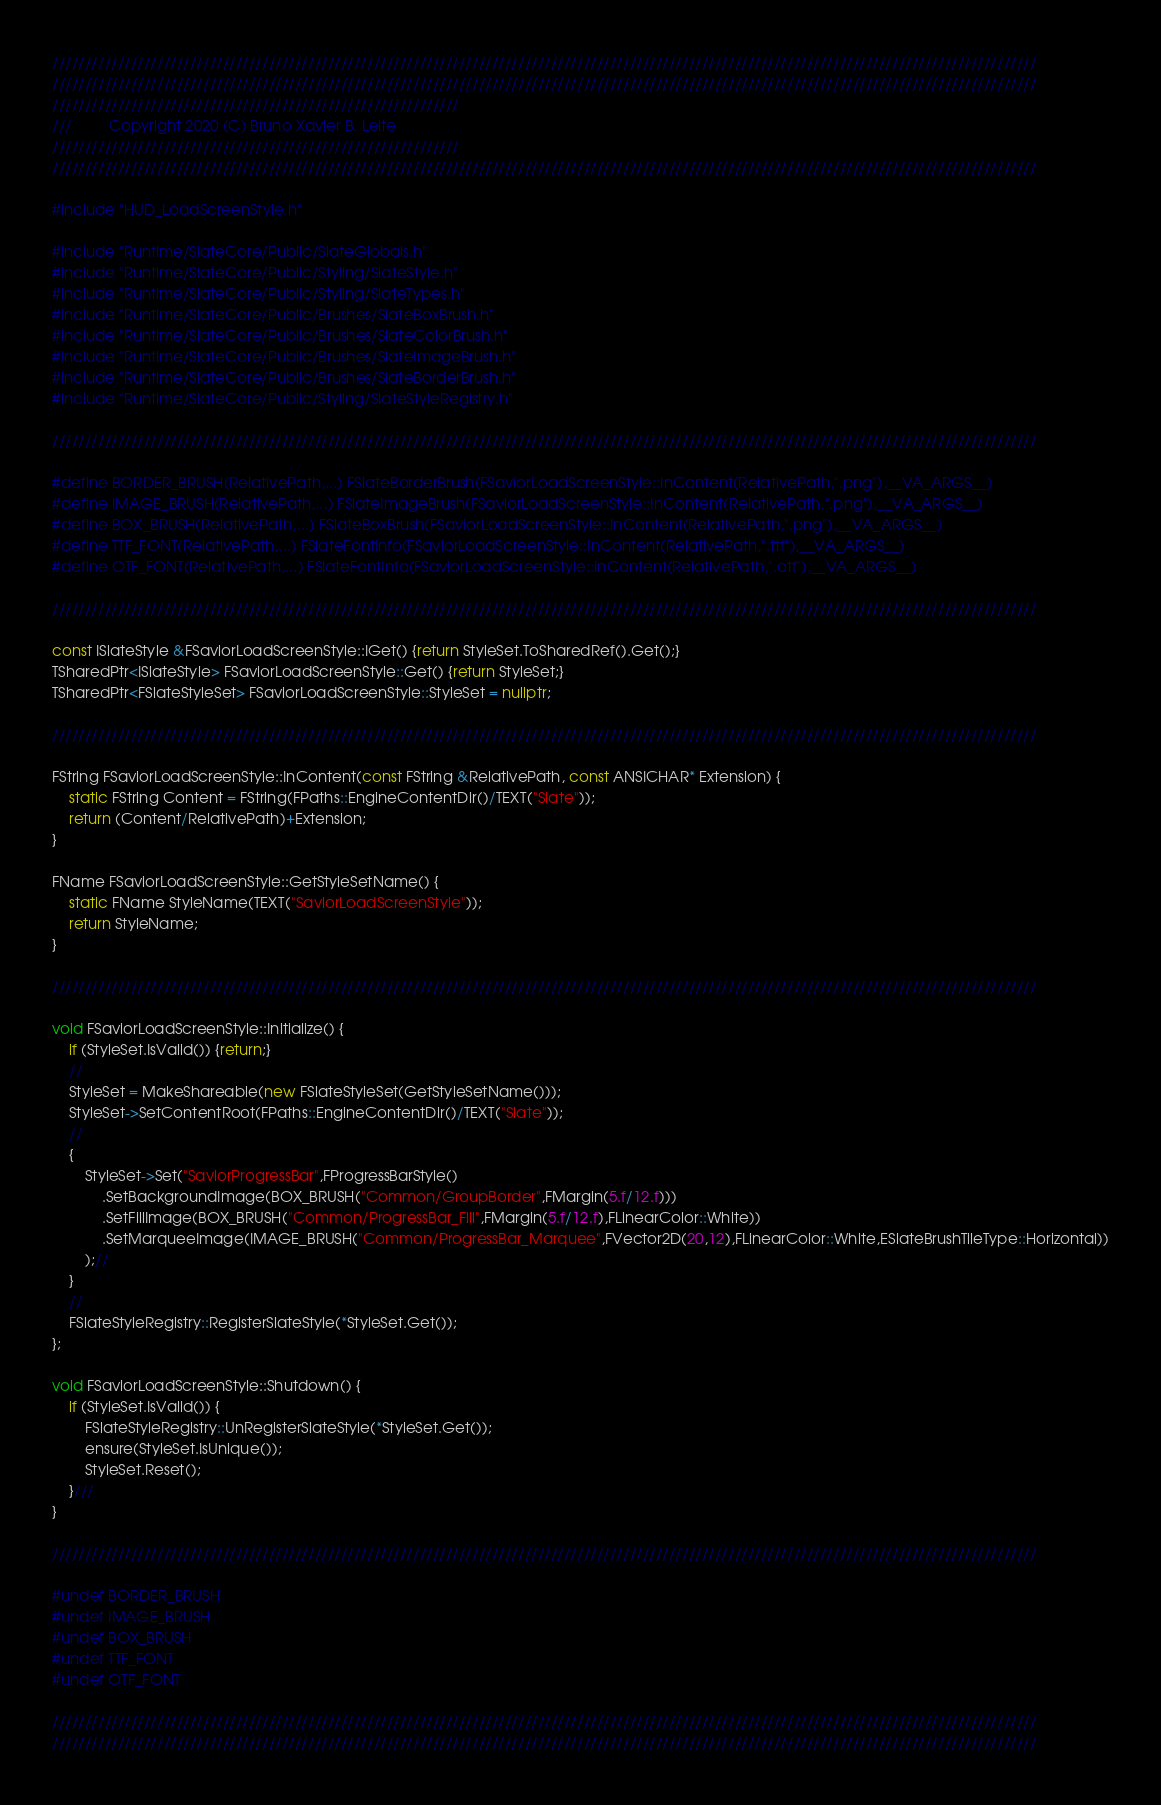<code> <loc_0><loc_0><loc_500><loc_500><_C++_>//////////////////////////////////////////////////////////////////////////////////////////////////////////////////////////////////////////////////////
//////////////////////////////////////////////////////////////////////////////////////////////////////////////////////////////////////////////////////
//////////////////////////////////////////////////////////////
///			Copyright 2020 (C) Bruno Xavier B. Leite
//////////////////////////////////////////////////////////////
//////////////////////////////////////////////////////////////////////////////////////////////////////////////////////////////////////////////////////

#include "HUD_LoadScreenStyle.h"

#include "Runtime/SlateCore/Public/SlateGlobals.h"
#include "Runtime/SlateCore/Public/Styling/SlateStyle.h"
#include "Runtime/SlateCore/Public/Styling/SlateTypes.h"
#include "Runtime/SlateCore/Public/Brushes/SlateBoxBrush.h"
#include "Runtime/SlateCore/Public/Brushes/SlateColorBrush.h"
#include "Runtime/SlateCore/Public/Brushes/SlateImageBrush.h"
#include "Runtime/SlateCore/Public/Brushes/SlateBorderBrush.h"
#include "Runtime/SlateCore/Public/Styling/SlateStyleRegistry.h"

//////////////////////////////////////////////////////////////////////////////////////////////////////////////////////////////////////////////////////

#define BORDER_BRUSH(RelativePath,...) FSlateBorderBrush(FSaviorLoadScreenStyle::InContent(RelativePath,".png"),__VA_ARGS__)
#define IMAGE_BRUSH(RelativePath,...) FSlateImageBrush(FSaviorLoadScreenStyle::InContent(RelativePath,".png"),__VA_ARGS__)
#define BOX_BRUSH(RelativePath,...) FSlateBoxBrush(FSaviorLoadScreenStyle::InContent(RelativePath,".png"),__VA_ARGS__)
#define TTF_FONT(RelativePath,...) FSlateFontInfo(FSaviorLoadScreenStyle::InContent(RelativePath,".ttf"),__VA_ARGS__)
#define OTF_FONT(RelativePath,...) FSlateFontInfo(FSaviorLoadScreenStyle::InContent(RelativePath,".otf"),__VA_ARGS__)

//////////////////////////////////////////////////////////////////////////////////////////////////////////////////////////////////////////////////////

const ISlateStyle &FSaviorLoadScreenStyle::IGet() {return StyleSet.ToSharedRef().Get();}
TSharedPtr<ISlateStyle> FSaviorLoadScreenStyle::Get() {return StyleSet;}
TSharedPtr<FSlateStyleSet> FSaviorLoadScreenStyle::StyleSet = nullptr;

//////////////////////////////////////////////////////////////////////////////////////////////////////////////////////////////////////////////////////

FString FSaviorLoadScreenStyle::InContent(const FString &RelativePath, const ANSICHAR* Extension) {
	static FString Content = FString(FPaths::EngineContentDir()/TEXT("Slate"));
	return (Content/RelativePath)+Extension;
}

FName FSaviorLoadScreenStyle::GetStyleSetName() {
	static FName StyleName(TEXT("SaviorLoadScreenStyle"));
	return StyleName;
}

//////////////////////////////////////////////////////////////////////////////////////////////////////////////////////////////////////////////////////

void FSaviorLoadScreenStyle::Initialize() {
	if (StyleSet.IsValid()) {return;}
	//
	StyleSet = MakeShareable(new FSlateStyleSet(GetStyleSetName()));
	StyleSet->SetContentRoot(FPaths::EngineContentDir()/TEXT("Slate"));
	//
	{
		StyleSet->Set("SaviorProgressBar",FProgressBarStyle()
			.SetBackgroundImage(BOX_BRUSH("Common/GroupBorder",FMargin(5.f/12.f)))
			.SetFillImage(BOX_BRUSH("Common/ProgressBar_Fill",FMargin(5.f/12.f),FLinearColor::White))
			.SetMarqueeImage(IMAGE_BRUSH("Common/ProgressBar_Marquee",FVector2D(20,12),FLinearColor::White,ESlateBrushTileType::Horizontal))
		);//
	}
	//
	FSlateStyleRegistry::RegisterSlateStyle(*StyleSet.Get());
};

void FSaviorLoadScreenStyle::Shutdown() {
	if (StyleSet.IsValid()) {
		FSlateStyleRegistry::UnRegisterSlateStyle(*StyleSet.Get());
		ensure(StyleSet.IsUnique());
		StyleSet.Reset();
	}///
}

//////////////////////////////////////////////////////////////////////////////////////////////////////////////////////////////////////////////////////

#undef BORDER_BRUSH
#undef IMAGE_BRUSH
#undef BOX_BRUSH
#undef TTF_FONT
#undef OTF_FONT

//////////////////////////////////////////////////////////////////////////////////////////////////////////////////////////////////////////////////////
//////////////////////////////////////////////////////////////////////////////////////////////////////////////////////////////////////////////////////</code> 